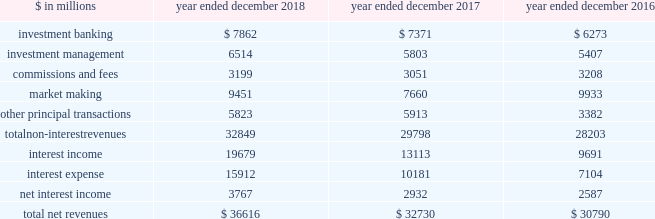The goldman sachs group , inc .
And subsidiaries management 2019s discussion and analysis net revenues the table below presents net revenues by line item. .
In the table above : 2030 investment banking consists of revenues ( excluding net interest ) from financial advisory and underwriting assignments , as well as derivative transactions directly related to these assignments .
These activities are included in our investment banking segment .
2030 investment management consists of revenues ( excluding net interest ) from providing investment management services to a diverse set of clients , as well as wealth advisory services and certain transaction services to high-net-worth individuals and families .
These activities are included in our investment management segment .
2030 commissions and fees consists of revenues from executing and clearing client transactions on major stock , options and futures exchanges worldwide , as well as over-the-counter ( otc ) transactions .
These activities are included in our institutional client services and investment management segments .
2030 market making consists of revenues ( excluding net interest ) from client execution activities related to making markets in interest rate products , credit products , mortgages , currencies , commodities and equity products .
These activities are included in our institutional client services segment .
2030 other principal transactions consists of revenues ( excluding net interest ) from our investing activities and the origination of loans to provide financing to clients .
In addition , other principal transactions includes revenues related to our consolidated investments .
These activities are included in our investing & lending segment .
Provision for credit losses , previously reported in other principal transactions revenues , is now reported as a separate line item in the consolidated statements of earnings .
Previously reported amounts have been conformed to the current presentation .
Operating environment .
During 2018 , our market- making activities reflected generally higher levels of volatility and improved client activity , compared with a low volatility environment in 2017 .
In investment banking , industry-wide mergers and acquisitions volumes increased compared with 2017 , while industry-wide underwriting transactions decreased .
Our other principal transactions revenues benefited from company-specific events , including sales , and strong corporate performance , while investments in public equities reflected losses , as global equity prices generally decreased in 2018 , particularly towards the end of the year .
In investment management , our assets under supervision increased reflecting net inflows in liquidity products , fixed income assets and equity assets , partially offset by depreciation in client assets , primarily in equity assets .
If market-making or investment banking activity levels decline , or assets under supervision decline , or asset prices continue to decline , net revenues would likely be negatively impacted .
See 201csegment operating results 201d for further information about the operating environment and material trends and uncertainties that may impact our results of operations .
During 2017 , generally higher asset prices and tighter credit spreads were supportive of industry-wide underwriting activities , investment management performance and other principal transactions .
However , low levels of volatility in equity , fixed income , currency and commodity markets continued to negatively affect our market-making activities .
2018 versus 2017 net revenues in the consolidated statements of earnings were $ 36.62 billion for 2018 , 12% ( 12 % ) higher than 2017 , primarily due to significantly higher market making revenues and net interest income , as well as higher investment management revenues and investment banking revenues .
Non-interest revenues .
Investment banking revenues in the consolidated statements of earnings were $ 7.86 billion for 2018 , 7% ( 7 % ) higher than 2017 .
Revenues in financial advisory were higher , reflecting an increase in industry-wide completed mergers and acquisitions volumes .
Revenues in underwriting were slightly higher , due to significantly higher revenues in equity underwriting , driven by initial public offerings , partially offset by lower revenues in debt underwriting , reflecting a decline in leveraged finance activity .
Investment management revenues in the consolidated statements of earnings were $ 6.51 billion for 2018 , 12% ( 12 % ) higher than 2017 , primarily due to significantly higher incentive fees , as a result of harvesting .
Management and other fees were also higher , reflecting higher average assets under supervision and the impact of the recently adopted revenue recognition standard , partially offset by shifts in the mix of client assets and strategies .
See note 3 to the consolidated financial statements for further information about asu no .
2014-09 , 201crevenue from contracts with customers ( topic 606 ) . 201d 52 goldman sachs 2018 form 10-k .
What is the growth rate in net revenues in 2017? 
Computations: ((32730 - 30790) / 30790)
Answer: 0.06301. 